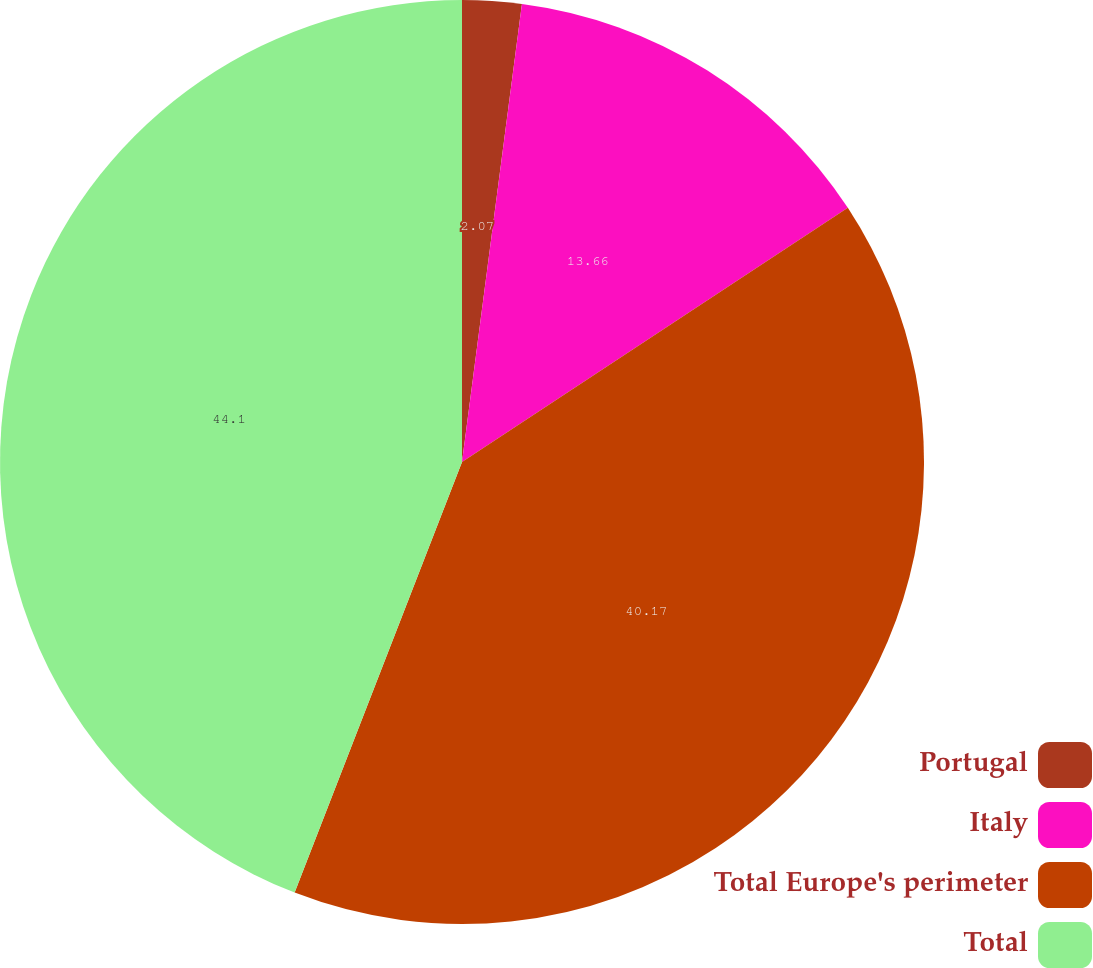Convert chart. <chart><loc_0><loc_0><loc_500><loc_500><pie_chart><fcel>Portugal<fcel>Italy<fcel>Total Europe's perimeter<fcel>Total<nl><fcel>2.07%<fcel>13.66%<fcel>40.17%<fcel>44.1%<nl></chart> 